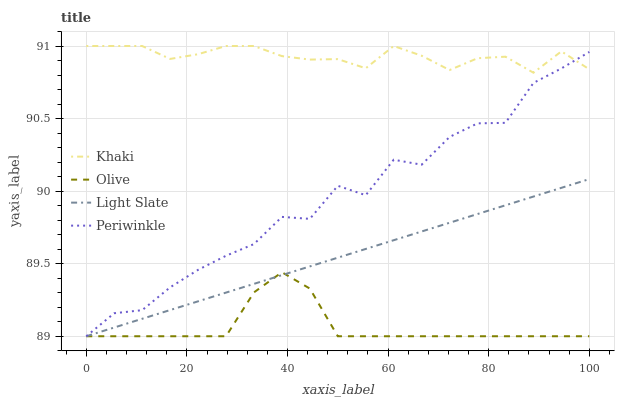Does Olive have the minimum area under the curve?
Answer yes or no. Yes. Does Khaki have the maximum area under the curve?
Answer yes or no. Yes. Does Light Slate have the minimum area under the curve?
Answer yes or no. No. Does Light Slate have the maximum area under the curve?
Answer yes or no. No. Is Light Slate the smoothest?
Answer yes or no. Yes. Is Periwinkle the roughest?
Answer yes or no. Yes. Is Khaki the smoothest?
Answer yes or no. No. Is Khaki the roughest?
Answer yes or no. No. Does Olive have the lowest value?
Answer yes or no. Yes. Does Khaki have the lowest value?
Answer yes or no. No. Does Khaki have the highest value?
Answer yes or no. Yes. Does Light Slate have the highest value?
Answer yes or no. No. Is Light Slate less than Khaki?
Answer yes or no. Yes. Is Khaki greater than Olive?
Answer yes or no. Yes. Does Olive intersect Periwinkle?
Answer yes or no. Yes. Is Olive less than Periwinkle?
Answer yes or no. No. Is Olive greater than Periwinkle?
Answer yes or no. No. Does Light Slate intersect Khaki?
Answer yes or no. No. 